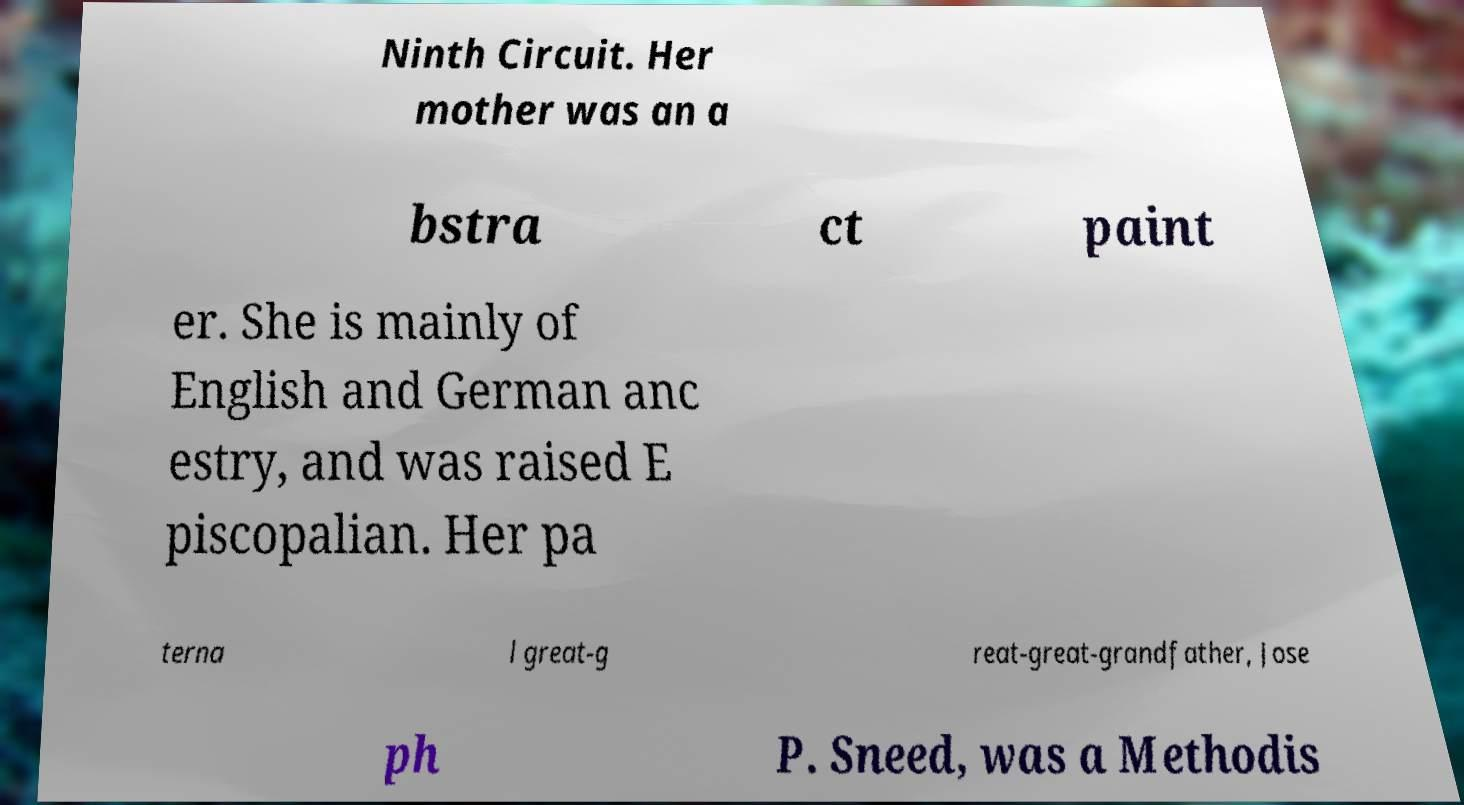There's text embedded in this image that I need extracted. Can you transcribe it verbatim? Ninth Circuit. Her mother was an a bstra ct paint er. She is mainly of English and German anc estry, and was raised E piscopalian. Her pa terna l great-g reat-great-grandfather, Jose ph P. Sneed, was a Methodis 